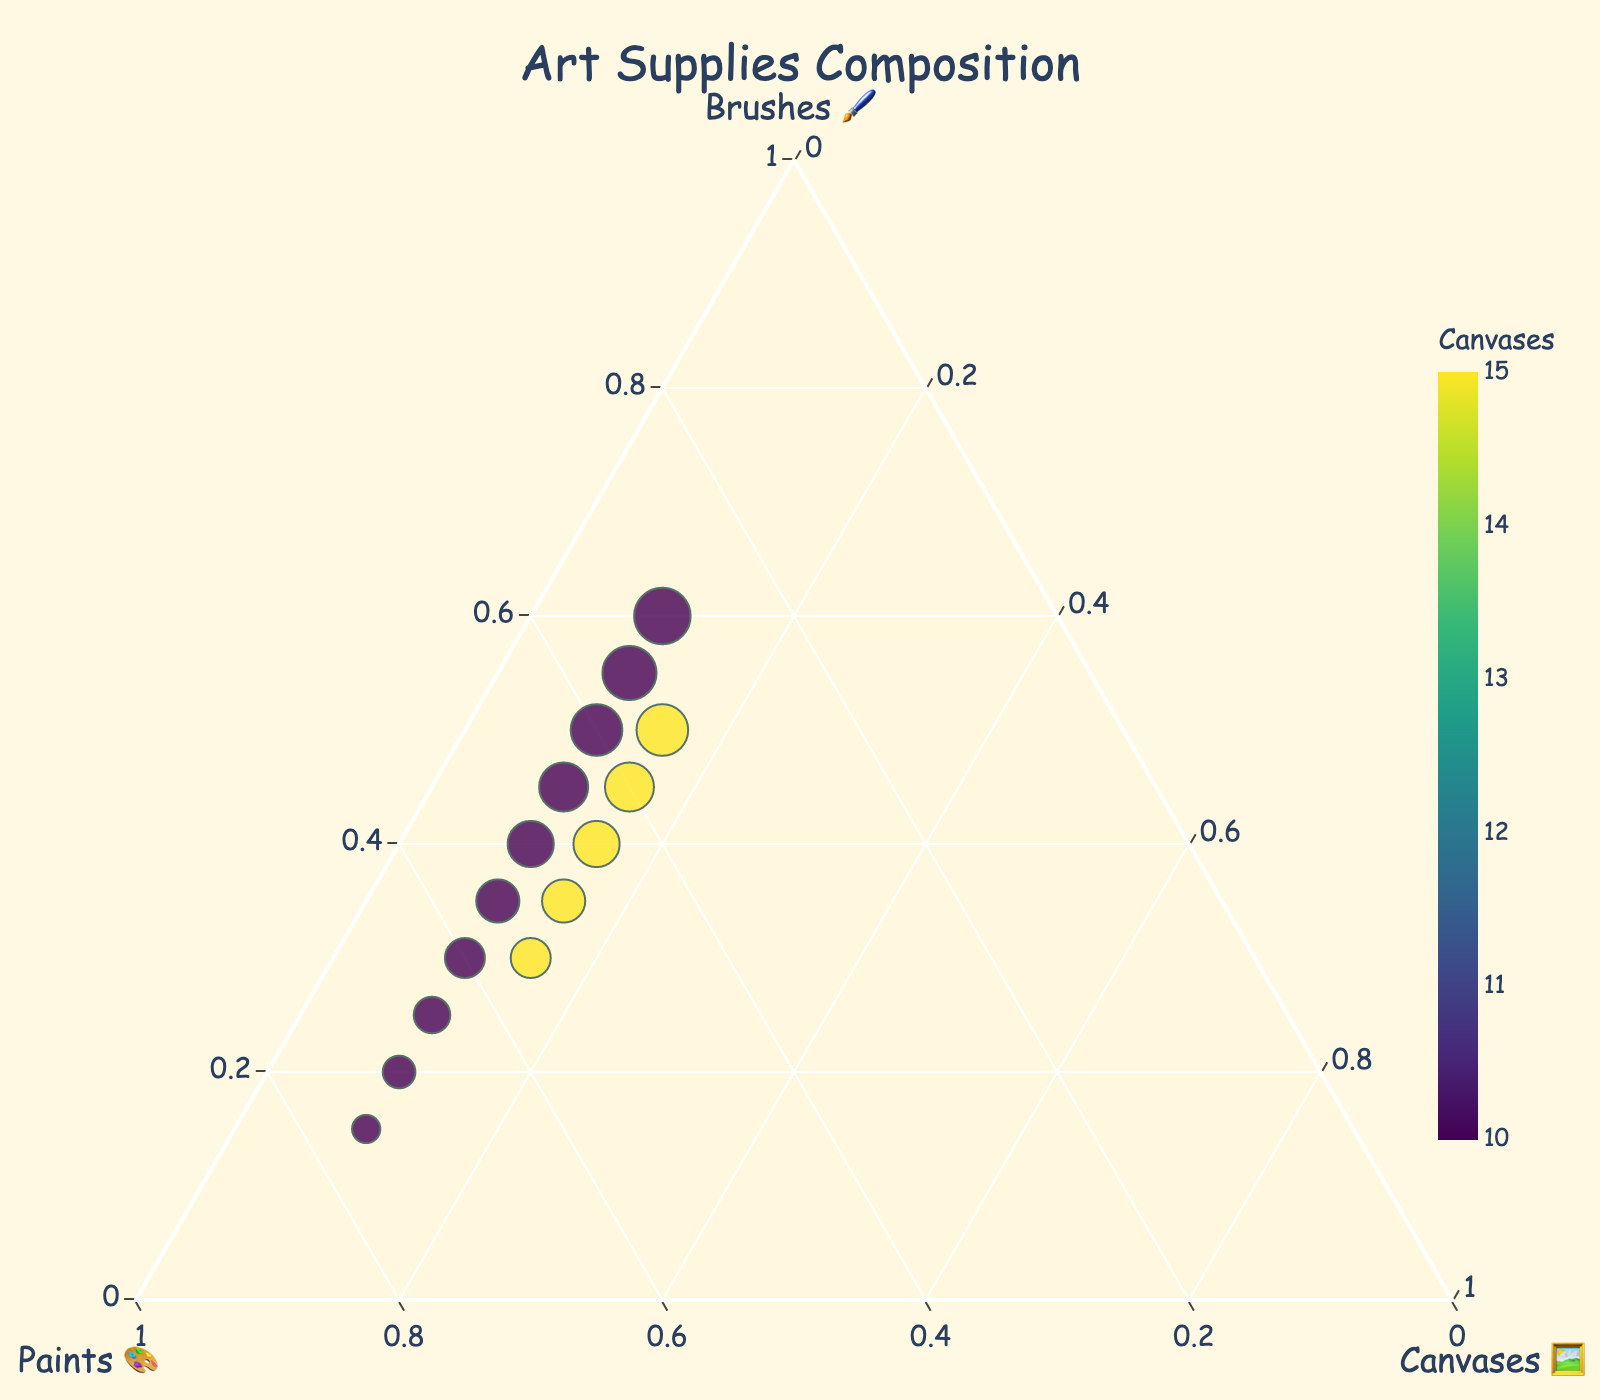What's the title of the figure? The title is given at the top of the figure and usually summarizes the main idea of the plot.
Answer: Art Supplies Composition How many data points are in the figure? Each data point represents a composition of art supplies usage, and by counting each dot in the figure, you can find the total number.
Answer: 15 Which supply has the highest value in the data points where the number of canvases is 15? Look at the points where canvases is 15 and compare the values of brushes and paints among those points.
Answer: Paints Do all points align where the brushes, paints, and canvases add up to 100? Since this is a requirement for ternary plots, all points should follow \(Brushes + Paints + Canvases = 100\). Verify each data point.
Answer: Yes What's the range of brushes used? Identify the minimum and maximum values on the brushes axis of the ternary plot.
Answer: 15-60 Which data point has the highest number of brushes? Examine the figure for the point that reaches the furthest along the brushes axis.
Answer: 60 brushes, 30 paints, and 10 canvases When the number of canvases is 15, what is the average number of brushes used? Identify the points where canvases are 15, sum the brushes values, and divide by the number of these points.
Answer: 40 brushes How does the color of the points change as the number of canvases increases? Observe the color gradient applied to the points and how it changes across the canvases axis.
Answer: From dark to lighter green What is the relationship between brushes and paints use? Check the distribution and trend of data points along the brushes and paints axes.
Answer: As brushes increase, paints generally decrease How many groups of data points there are based on canvases values? Determine distinct categories based on the canvases axis and count them.
Answer: 2 groups (10 and 15 canvases) 